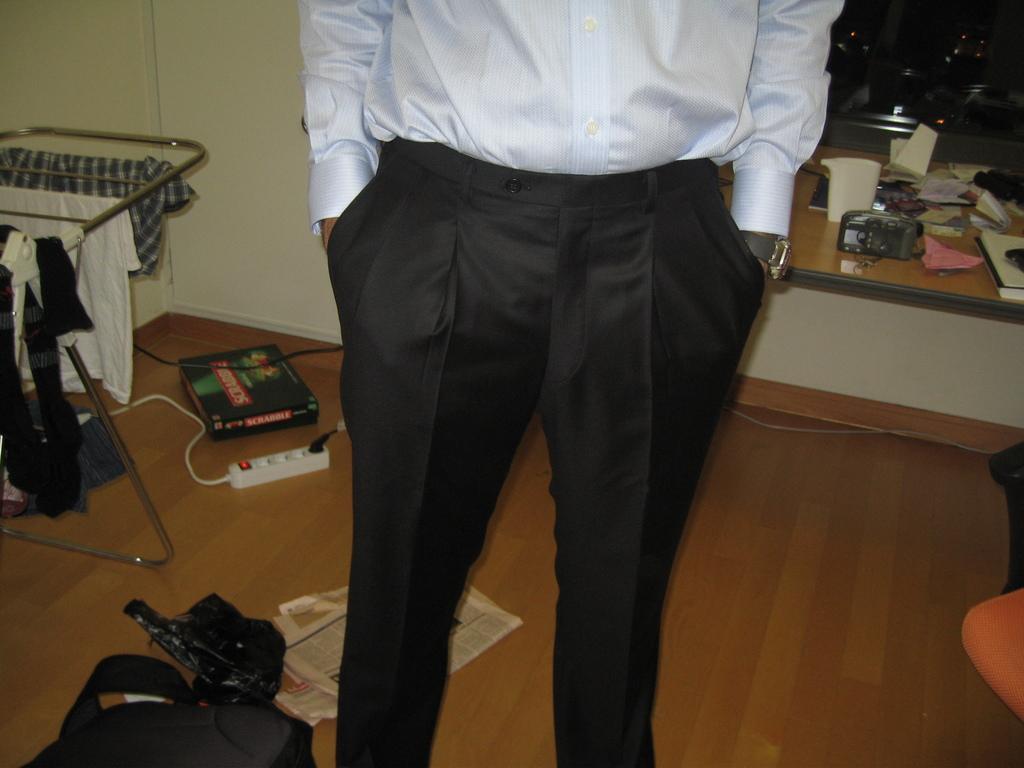Can you describe this image briefly? This picture is taken inside the room. In this image, in the middle, we can see a man standing. On the right side corner there is a chair, we can also see a table on the right side. On that table, there are some papers, books, jar. On the left side, we can also see some books, switchboard, clothes. In the background, there is a wall. 